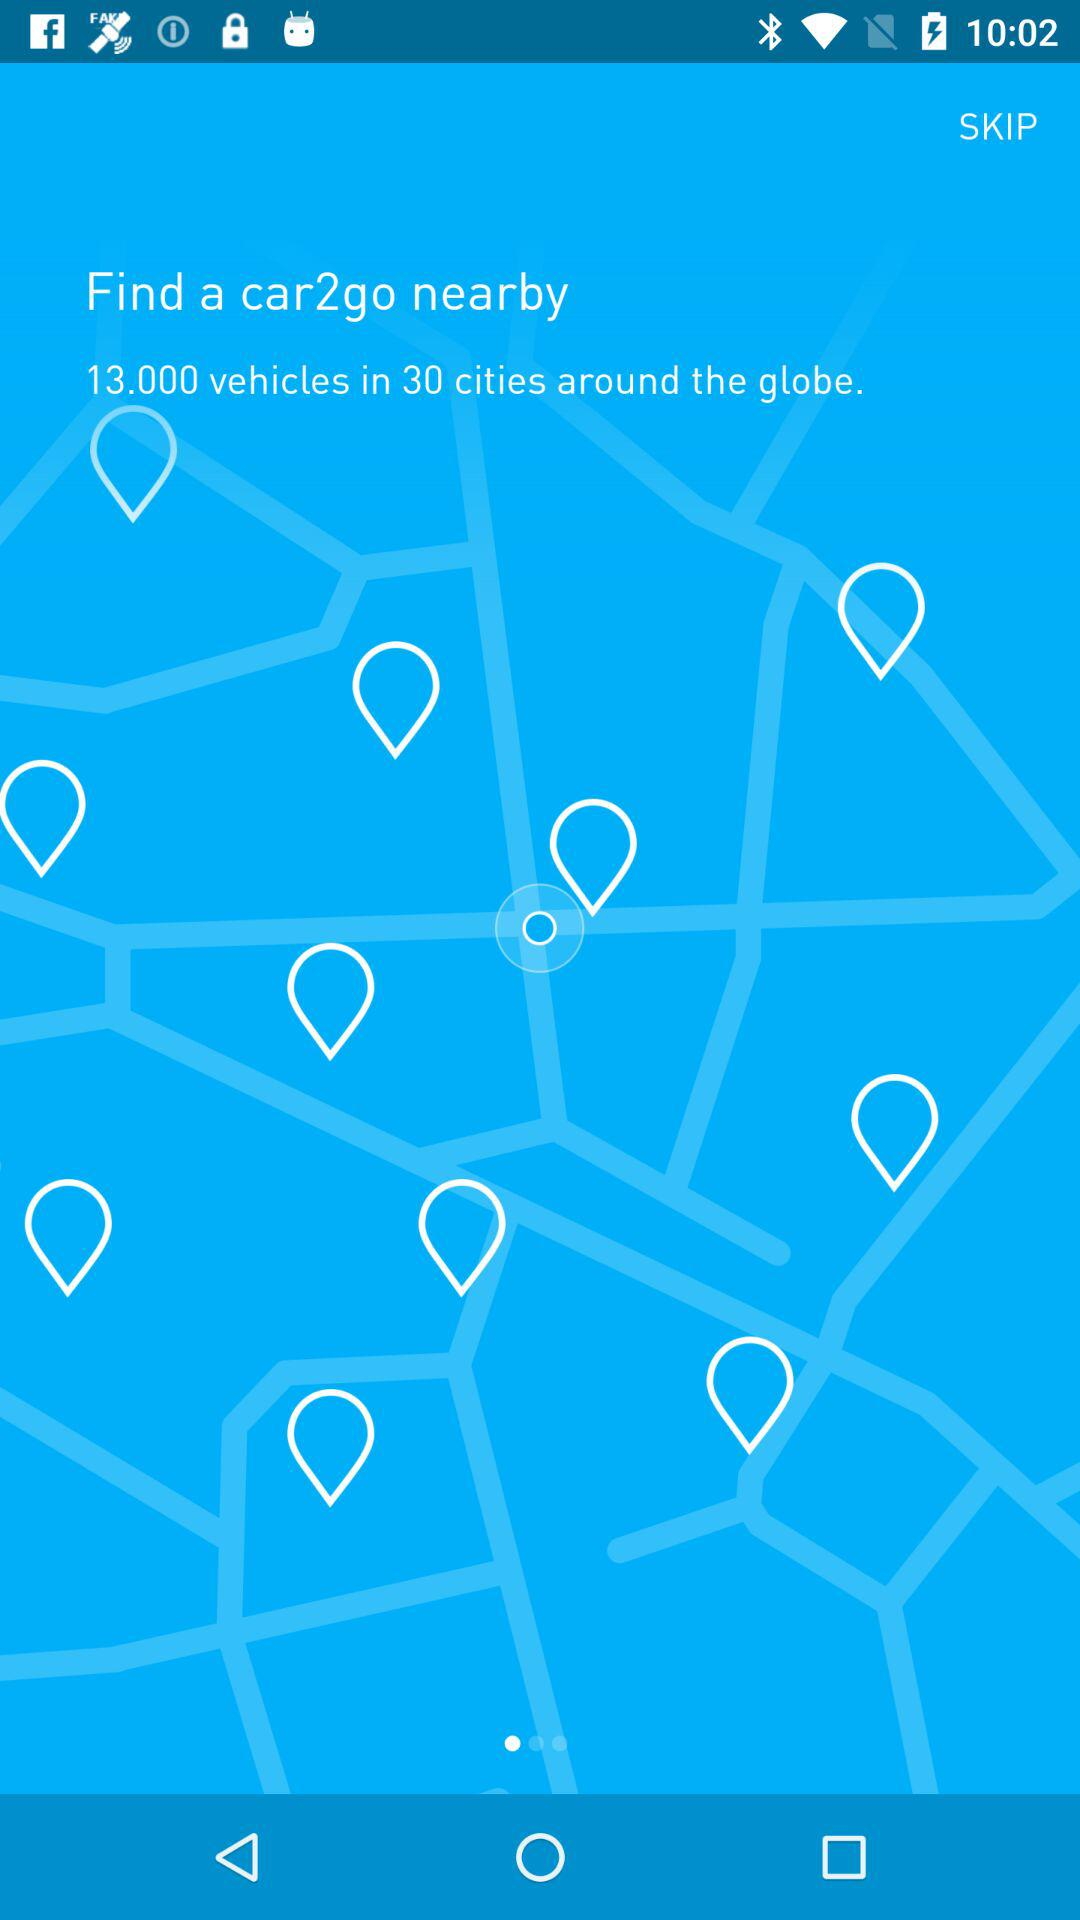How many vehicles are there in 30 cities around the globe? There are 13,000 vehicles in 30 cities around the globe. 